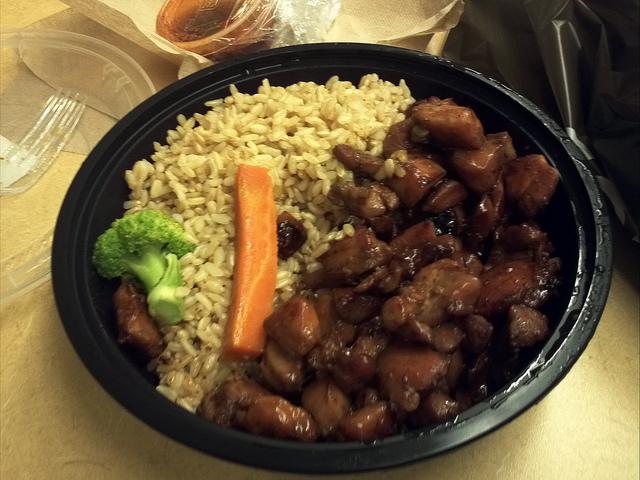Are there any vegetables in the dish?
Write a very short answer. Yes. What type of bowl is shown?
Concise answer only. Plastic. Is this a vegetable soup?
Short answer required. No. Where is the food?
Quick response, please. Bowl. What is the green vegetable in the picture?
Answer briefly. Broccoli. What kind of food is this?
Quick response, please. Chinese. 